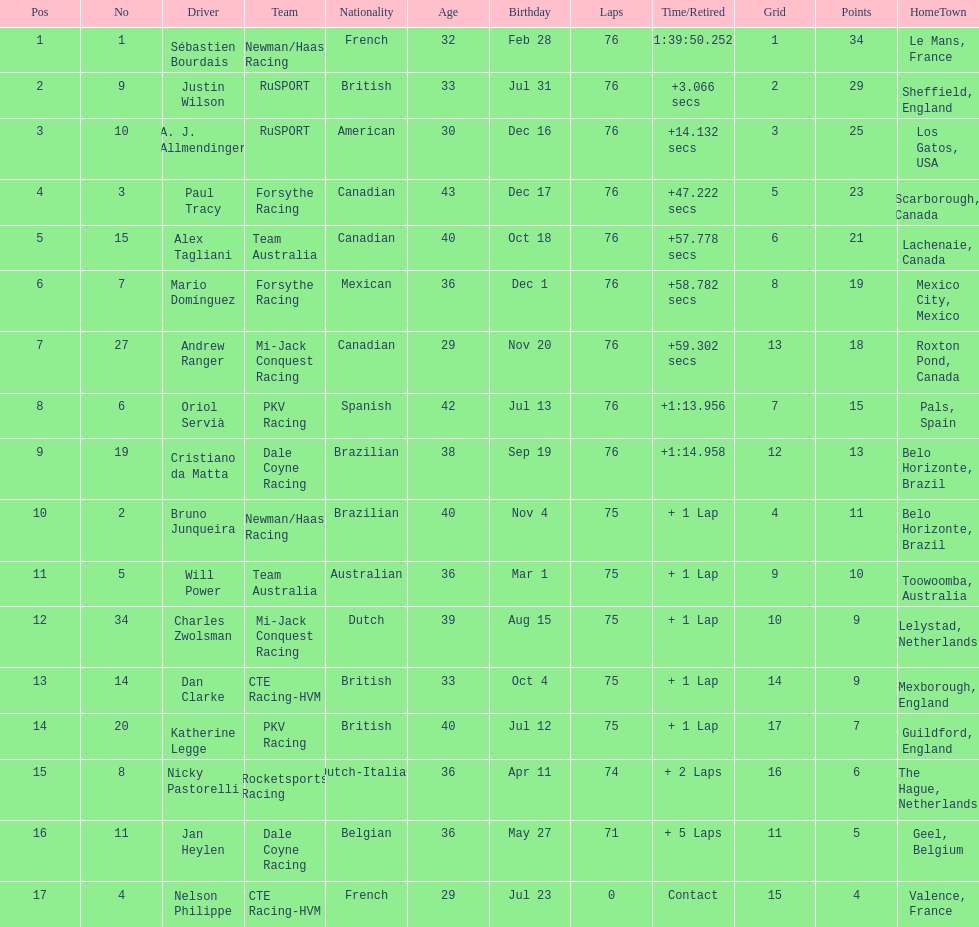What was the total points that canada earned together? 62. 